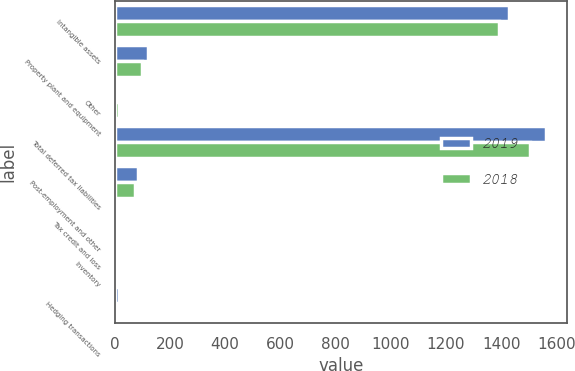Convert chart to OTSL. <chart><loc_0><loc_0><loc_500><loc_500><stacked_bar_chart><ecel><fcel>Intangible assets<fcel>Property plant and equipment<fcel>Other<fcel>Total deferred tax liabilities<fcel>Post-employment and other<fcel>Tax credit and loss<fcel>Inventory<fcel>Hedging transactions<nl><fcel>2019<fcel>1428.3<fcel>120.5<fcel>13.4<fcel>1562.2<fcel>84.9<fcel>10<fcel>7.6<fcel>15.6<nl><fcel>2018<fcel>1393.6<fcel>98.5<fcel>14.2<fcel>1506.3<fcel>75.5<fcel>0.2<fcel>5.9<fcel>0.9<nl></chart> 